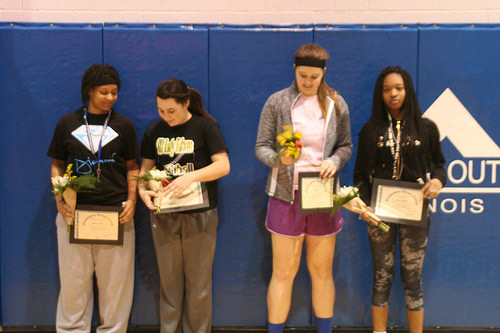<image>
Is there a girl next to the girl? Yes. The girl is positioned adjacent to the girl, located nearby in the same general area. 